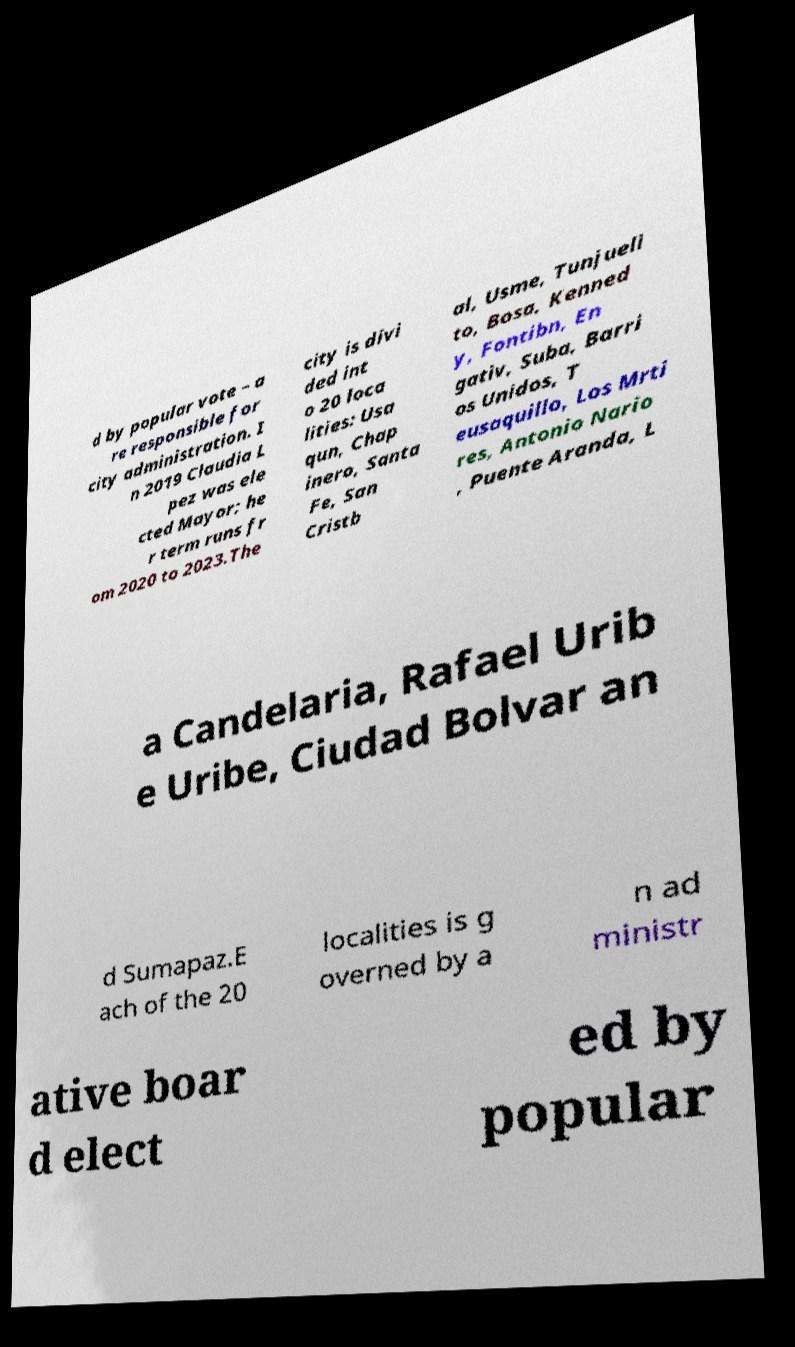I need the written content from this picture converted into text. Can you do that? d by popular vote – a re responsible for city administration. I n 2019 Claudia L pez was ele cted Mayor; he r term runs fr om 2020 to 2023.The city is divi ded int o 20 loca lities: Usa qun, Chap inero, Santa Fe, San Cristb al, Usme, Tunjueli to, Bosa, Kenned y, Fontibn, En gativ, Suba, Barri os Unidos, T eusaquillo, Los Mrti res, Antonio Nario , Puente Aranda, L a Candelaria, Rafael Urib e Uribe, Ciudad Bolvar an d Sumapaz.E ach of the 20 localities is g overned by a n ad ministr ative boar d elect ed by popular 